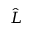<formula> <loc_0><loc_0><loc_500><loc_500>\hat { L }</formula> 